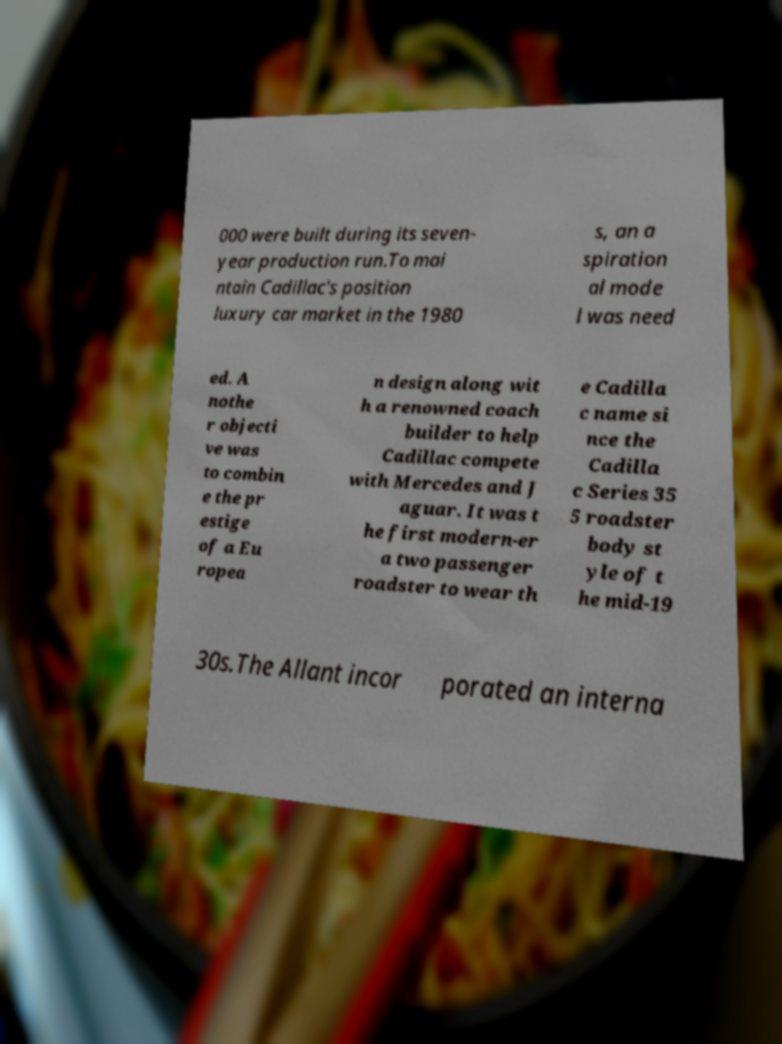Can you accurately transcribe the text from the provided image for me? 000 were built during its seven- year production run.To mai ntain Cadillac's position luxury car market in the 1980 s, an a spiration al mode l was need ed. A nothe r objecti ve was to combin e the pr estige of a Eu ropea n design along wit h a renowned coach builder to help Cadillac compete with Mercedes and J aguar. It was t he first modern-er a two passenger roadster to wear th e Cadilla c name si nce the Cadilla c Series 35 5 roadster body st yle of t he mid-19 30s.The Allant incor porated an interna 